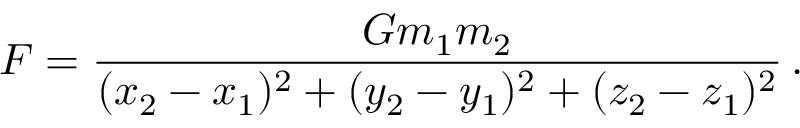<formula> <loc_0><loc_0><loc_500><loc_500>F = \frac { G m _ { 1 } m _ { 2 } } { ( x _ { 2 } - x _ { 1 } ) ^ { 2 } + ( y _ { 2 } - y _ { 1 } ) ^ { 2 } + ( z _ { 2 } - z _ { 1 } ) ^ { 2 } } \, .</formula> 